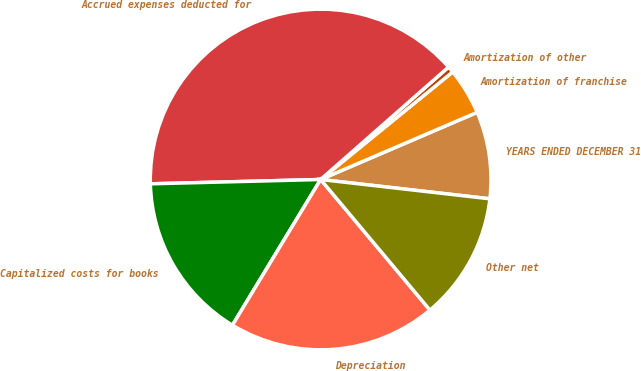Convert chart to OTSL. <chart><loc_0><loc_0><loc_500><loc_500><pie_chart><fcel>YEARS ENDED DECEMBER 31<fcel>Amortization of franchise<fcel>Amortization of other<fcel>Accrued expenses deducted for<fcel>Capitalized costs for books<fcel>Depreciation<fcel>Other net<nl><fcel>8.26%<fcel>4.43%<fcel>0.6%<fcel>38.93%<fcel>15.93%<fcel>19.76%<fcel>12.1%<nl></chart> 